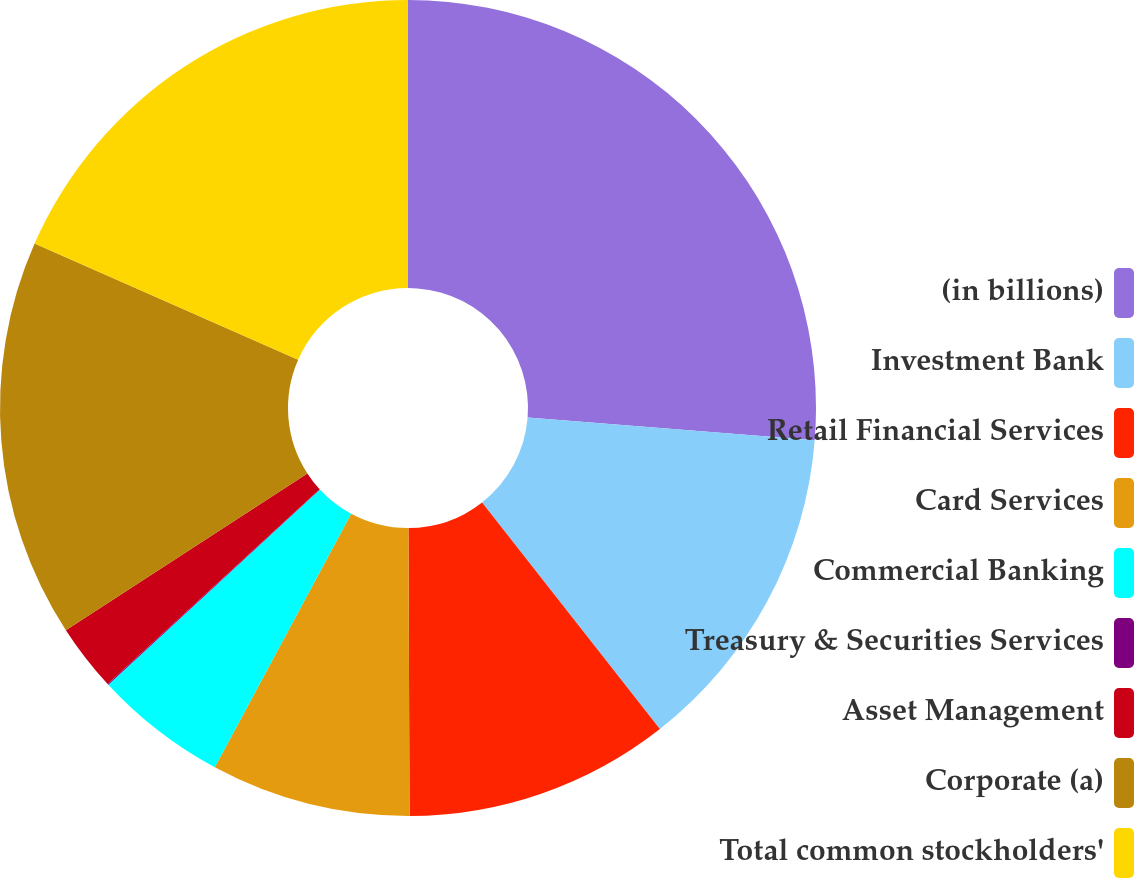Convert chart. <chart><loc_0><loc_0><loc_500><loc_500><pie_chart><fcel>(in billions)<fcel>Investment Bank<fcel>Retail Financial Services<fcel>Card Services<fcel>Commercial Banking<fcel>Treasury & Securities Services<fcel>Asset Management<fcel>Corporate (a)<fcel>Total common stockholders'<nl><fcel>26.26%<fcel>13.15%<fcel>10.53%<fcel>7.91%<fcel>5.28%<fcel>0.04%<fcel>2.66%<fcel>15.77%<fcel>18.4%<nl></chart> 